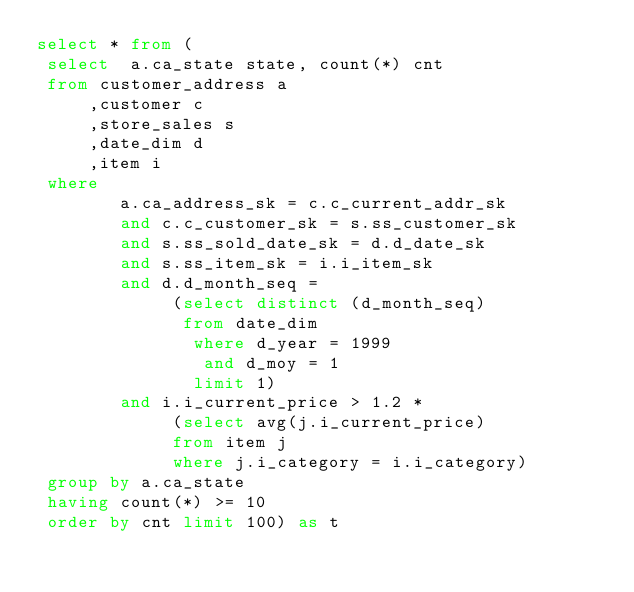<code> <loc_0><loc_0><loc_500><loc_500><_SQL_>select * from (
 select  a.ca_state state, count(*) cnt
 from customer_address a
     ,customer c
     ,store_sales s
     ,date_dim d
     ,item i
 where
        a.ca_address_sk = c.c_current_addr_sk
        and c.c_customer_sk = s.ss_customer_sk
        and s.ss_sold_date_sk = d.d_date_sk
        and s.ss_item_sk = i.i_item_sk
        and d.d_month_seq =
             (select distinct (d_month_seq)
              from date_dim
               where d_year = 1999
                and d_moy = 1
               limit 1)
        and i.i_current_price > 1.2 *
             (select avg(j.i_current_price)
             from item j
             where j.i_category = i.i_category)
 group by a.ca_state
 having count(*) >= 10
 order by cnt limit 100) as t
</code> 